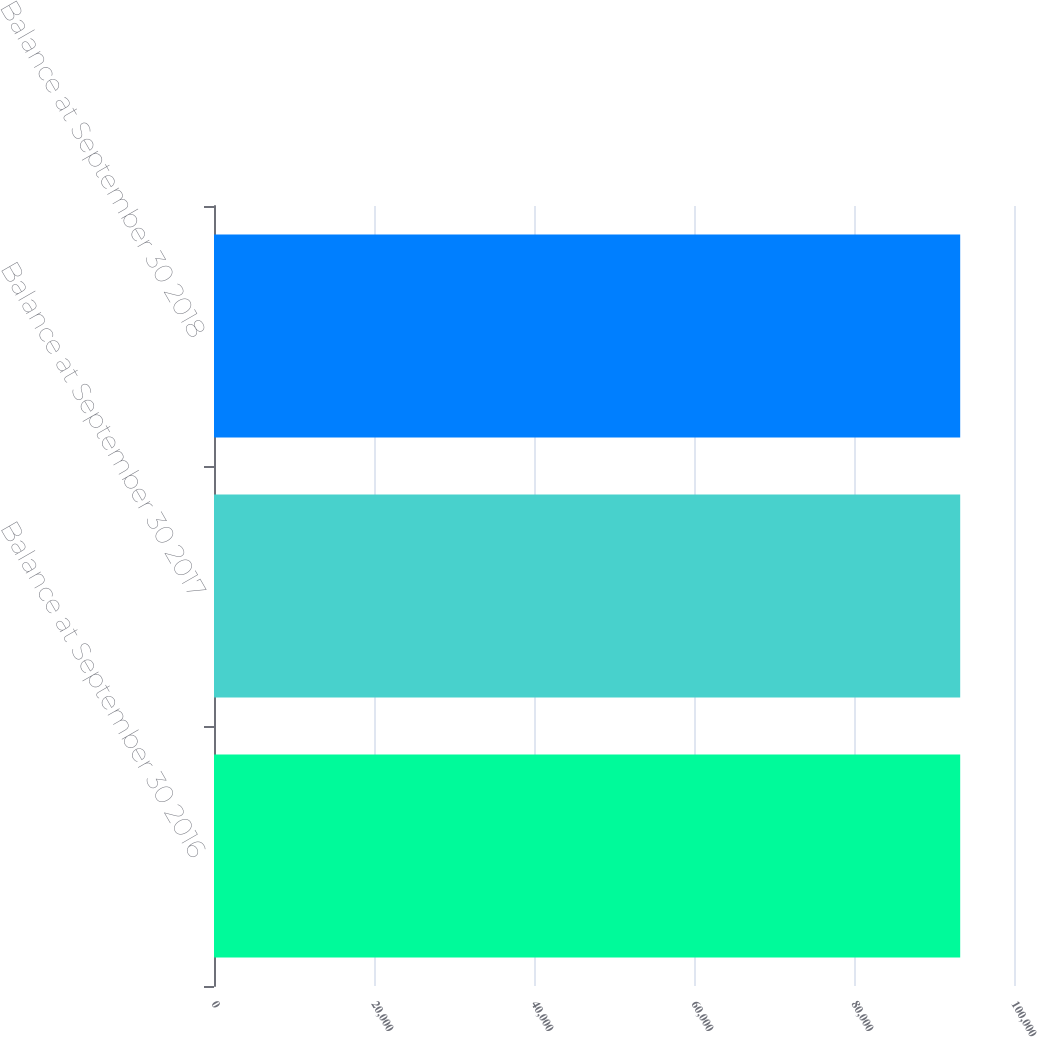<chart> <loc_0><loc_0><loc_500><loc_500><bar_chart><fcel>Balance at September 30 2016<fcel>Balance at September 30 2017<fcel>Balance at September 30 2018<nl><fcel>93275<fcel>93275.1<fcel>93275.2<nl></chart> 